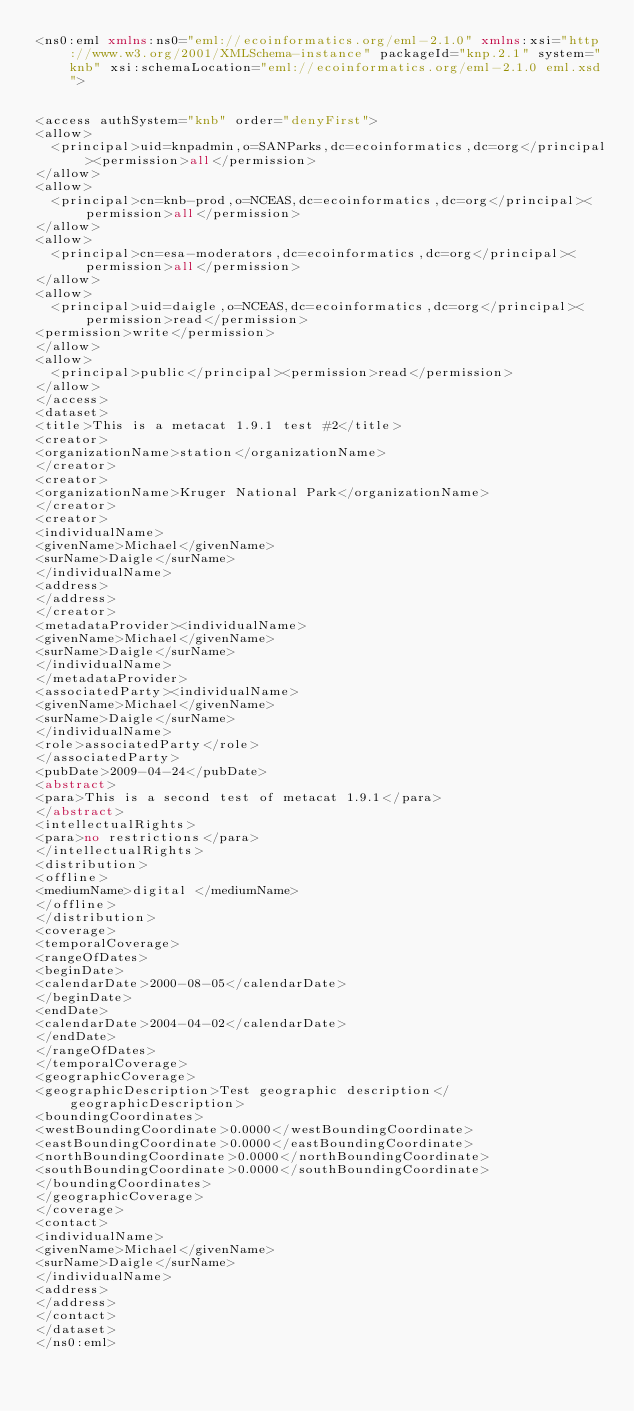Convert code to text. <code><loc_0><loc_0><loc_500><loc_500><_XML_><ns0:eml xmlns:ns0="eml://ecoinformatics.org/eml-2.1.0" xmlns:xsi="http://www.w3.org/2001/XMLSchema-instance" packageId="knp.2.1" system="knb" xsi:schemaLocation="eml://ecoinformatics.org/eml-2.1.0 eml.xsd">


<access authSystem="knb" order="denyFirst">
<allow>
  <principal>uid=knpadmin,o=SANParks,dc=ecoinformatics,dc=org</principal><permission>all</permission>
</allow>
<allow>
  <principal>cn=knb-prod,o=NCEAS,dc=ecoinformatics,dc=org</principal><permission>all</permission>
</allow>
<allow>
  <principal>cn=esa-moderators,dc=ecoinformatics,dc=org</principal><permission>all</permission>
</allow>
<allow>
  <principal>uid=daigle,o=NCEAS,dc=ecoinformatics,dc=org</principal><permission>read</permission>
<permission>write</permission>
</allow>
<allow>
  <principal>public</principal><permission>read</permission>
</allow>
</access>
<dataset>
<title>This is a metacat 1.9.1 test #2</title>
<creator>
<organizationName>station</organizationName>
</creator>
<creator>
<organizationName>Kruger National Park</organizationName>
</creator>
<creator>
<individualName>
<givenName>Michael</givenName>
<surName>Daigle</surName>
</individualName>
<address>
</address>
</creator>
<metadataProvider><individualName>
<givenName>Michael</givenName>
<surName>Daigle</surName>
</individualName>
</metadataProvider>
<associatedParty><individualName>
<givenName>Michael</givenName>
<surName>Daigle</surName>
</individualName>
<role>associatedParty</role>
</associatedParty>
<pubDate>2009-04-24</pubDate>
<abstract>
<para>This is a second test of metacat 1.9.1</para>
</abstract>
<intellectualRights>
<para>no restrictions</para>
</intellectualRights>
<distribution>
<offline>
<mediumName>digital </mediumName>
</offline>
</distribution>
<coverage>
<temporalCoverage>
<rangeOfDates>
<beginDate>
<calendarDate>2000-08-05</calendarDate>
</beginDate>
<endDate>
<calendarDate>2004-04-02</calendarDate>
</endDate>
</rangeOfDates>
</temporalCoverage>
<geographicCoverage>
<geographicDescription>Test geographic description</geographicDescription>
<boundingCoordinates>
<westBoundingCoordinate>0.0000</westBoundingCoordinate>
<eastBoundingCoordinate>0.0000</eastBoundingCoordinate>
<northBoundingCoordinate>0.0000</northBoundingCoordinate>
<southBoundingCoordinate>0.0000</southBoundingCoordinate>
</boundingCoordinates>
</geographicCoverage>
</coverage>
<contact>
<individualName>
<givenName>Michael</givenName>
<surName>Daigle</surName>
</individualName>
<address>
</address>
</contact>
</dataset>
</ns0:eml></code> 